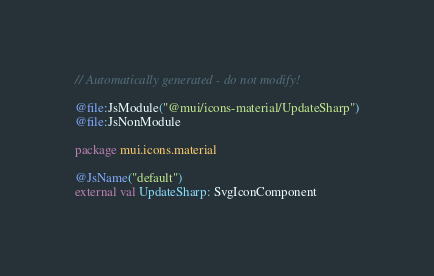Convert code to text. <code><loc_0><loc_0><loc_500><loc_500><_Kotlin_>// Automatically generated - do not modify!

@file:JsModule("@mui/icons-material/UpdateSharp")
@file:JsNonModule

package mui.icons.material

@JsName("default")
external val UpdateSharp: SvgIconComponent
</code> 